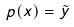Convert formula to latex. <formula><loc_0><loc_0><loc_500><loc_500>p ( x ) = \tilde { y }</formula> 